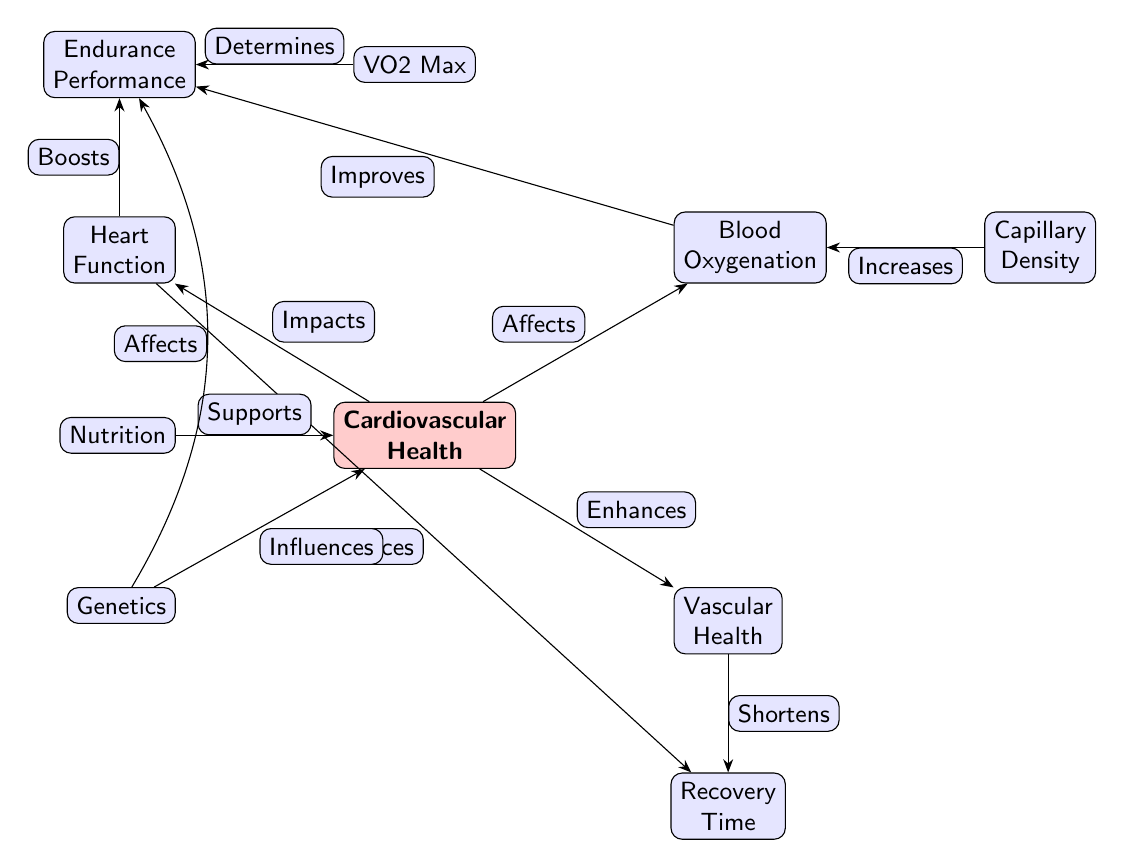What's at the top left of the diagram? The node at the top left is labeled "Heart Function." This can be identified by following the placement of the nodes in the diagram, which are organized around the central "Cardiovascular Health" node.
Answer: Heart Function How many nodes are there in total? By counting all the distinct labeled nodes in the diagram—Cardiovascular Health, Heart Function, Blood Oxygenation, Vascular Health, Endurance Performance, VO2 Max, Recovery Time, Capillary Density, Nutrition, and Genetics—we find there are ten nodes in total.
Answer: Ten What effect does Heart Function have on Endurance Performance? According to the diagram, Heart Function "Boosts" Endurance Performance. This relationship is shown by the directed edge connecting these two nodes with the annotation that describes the impact.
Answer: Boosts Which node influences Cardiovascular Health? The nodes "Genetics" and "Nutrition" influence Cardiovascular Health, as indicated by the edges connecting these two nodes to the "Cardiovascular Health" node with the respective annotations "Influences" and "Supports."
Answer: Genetics, Nutrition If Vascular Health shortens Recovery Time, what can you infer about their relationship? The inference from the diagram indicates that an increase in Vascular Health directly leads to a decrease in Recovery Time, which is shown by the directed edge connecting Vascular Health and Recovery Time with the annotation "Shortens." Thus, improving Vascular Health would likely decrease Recovery Time.
Answer: Vascular Health shortens Recovery Time What relationship exists between Blood Oxygenation and Endurance Performance? The diagram states that Blood Oxygenation "Improves" Endurance Performance, as indicated by the directed edge connecting the two nodes, indicating that better oxygen levels in the blood enhance performance capabilities during endurance activities.
Answer: Improves Which factor is indicated to determine VO2 Max? The diagram explicitly shows that VO2 Max is determined by "Endurance Performance," as depicted by the directed edge labeled "Determines" that connects these two nodes, signifying that VO2 Max is a function of the endurance performance levels.
Answer: Endurance Performance What supports Cardiovascular Health? According to the diagram, "Nutrition" supports Cardiovascular Health, as shown by the edge indicating the relationship and the word "Supports" accompanying the connection to the node.
Answer: Nutrition How does Genetics influence Endurance Performance? Genetics is shown to influence Endurance Performance in a non-direct manner, where it has a separate edge that connects to Cardiovascular Health as well as a bend that shows it affects Endurance Performance indirectly, demonstrating its overall role in impacting various aspects of athletic capacity.
Answer: Influences 